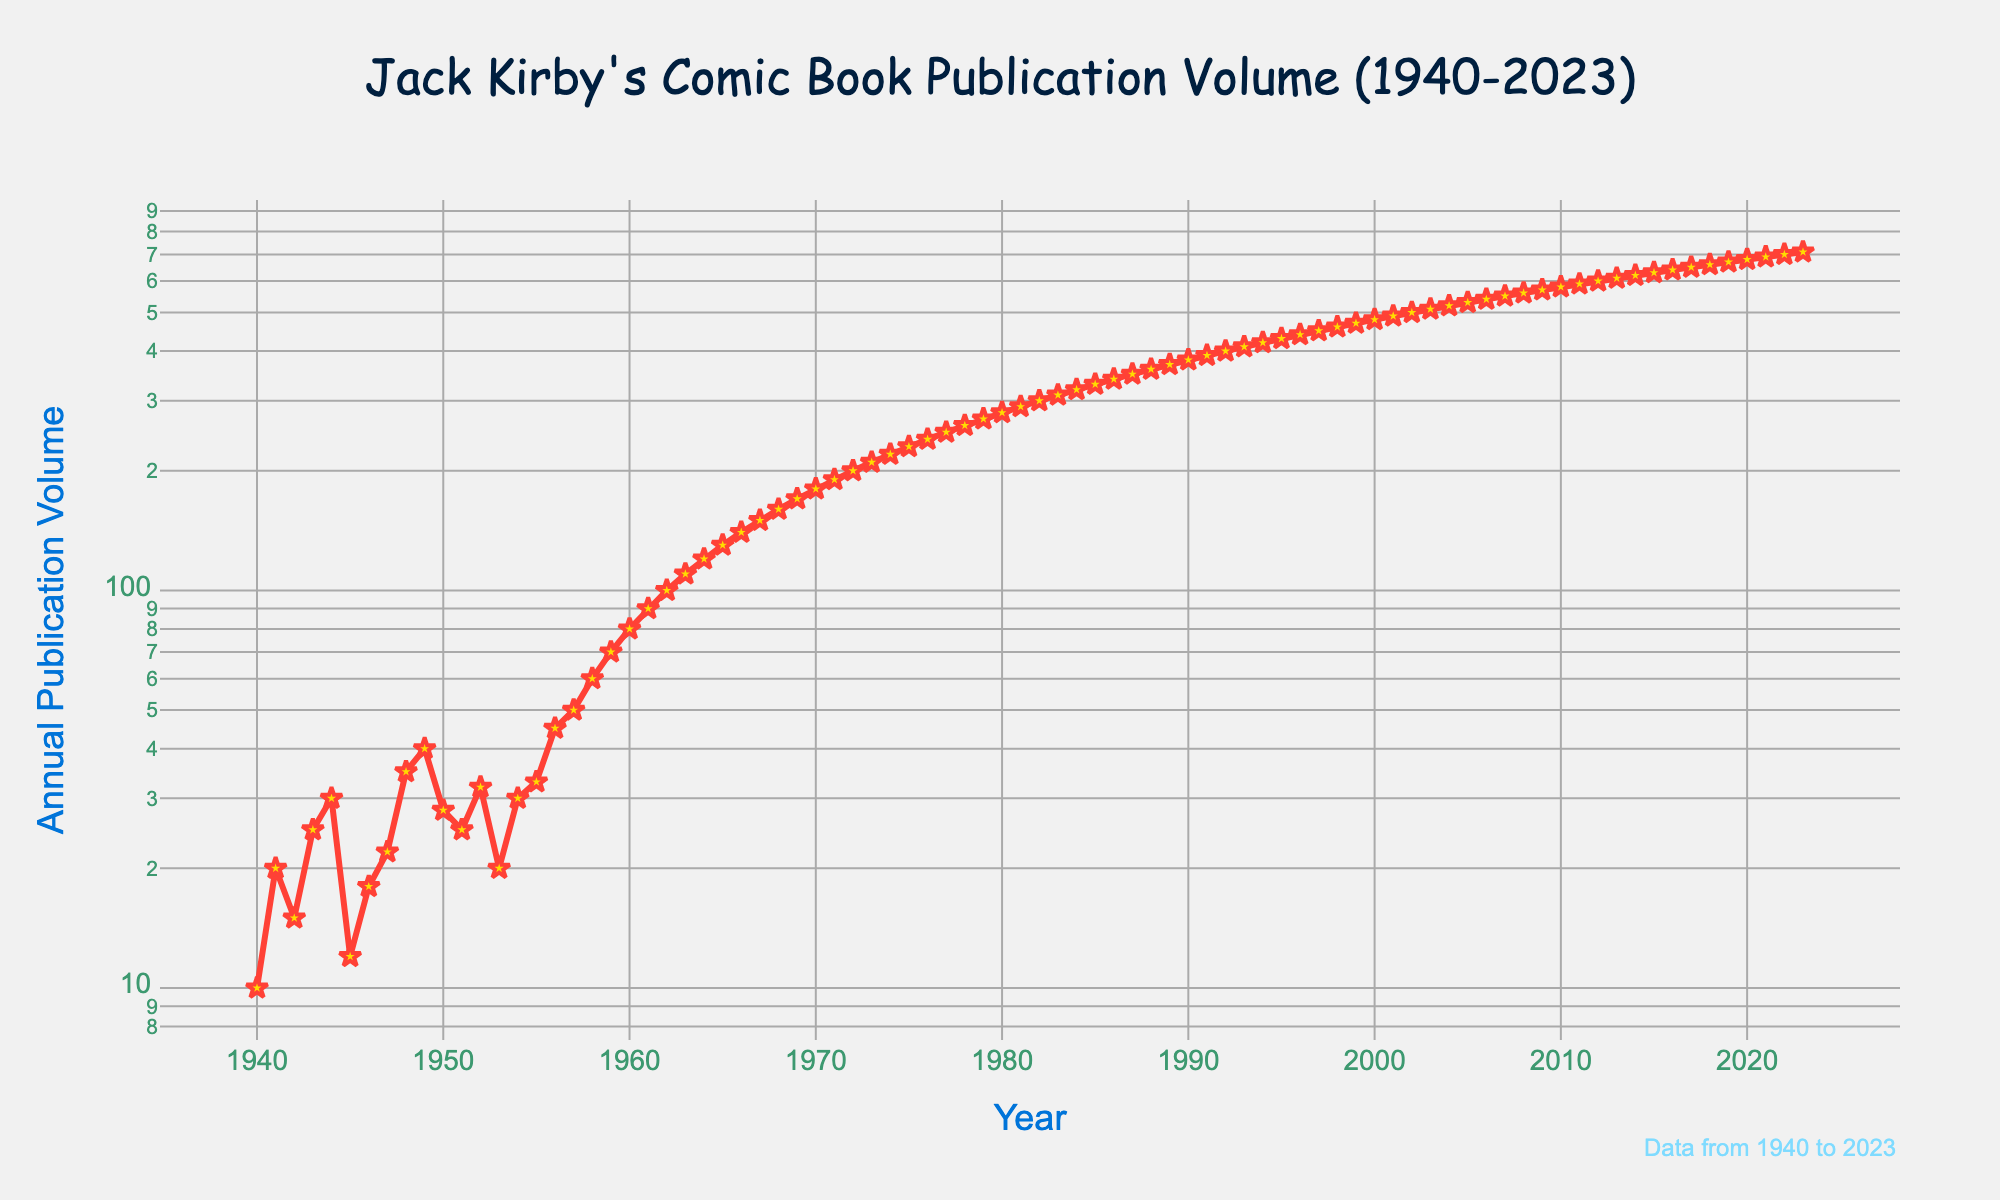What's the title of the plot? The title is displayed at the top of the figure. It reads: "Jack Kirby's Comic Book Publication Volume (1940-2023)".
Answer: Jack Kirby's Comic Book Publication Volume (1940-2023) What are the labels for the x-axis and y-axis? The x-axis and y-axis labels are displayed beneath and beside the axes. The x-axis is labeled "Year" and the y-axis is labeled "Annual Publication Volume".
Answer: Year; Annual Publication Volume What's the annual publication volume of Jack Kirby's comic books in the year 1958? Locate the year 1958 along the x-axis, then trace up to the corresponding y-axis value for that year. The volume for 1958 is 60.
Answer: 60 Is the publication volume consistently increasing from 1940 to 2023? Observing the trend of the line plot over time, we see that the volume generally increases, though there are small fluctuations. Overall, the trend shows an increasing pattern.
Answer: Yes Which year marks the first instance where the publication volume reaches 100? Locate where the y-axis value reaches 100 and trace horizontally to find the corresponding x-axis value. The year is 1962.
Answer: 1962 Between which two consecutive years was the greatest increase in publication volume observed? Examine the steepest segment of the line plot. The steepest segment, indicating the greatest increase, is from 1944 to 1945. This increase, however, is relative to the logarithmic scale.
Answer: 1944 to 1945 What's the median annual publication volume from 1940 to 2023? With 84 data points (years), the median is the average of the 42nd and 43rd values. The volumes for these years (1981 and 1982) are 290 and 300, respectively. The median is (290 + 300) / 2 = 295.
Answer: 295 How does the publication volume in 1940 compare to 2023? To compare visually, note the publication volumes for 1940 (10) and 2023 (710). There is a significant increase from 10 to 710 over the period.
Answer: 2023 is much higher During which decade did the publication volume first exceed 500? By locating the first instance on the y-axis above 500, we see that it occurs in the 2000s, specifically in 2002.
Answer: 2000s What's the approximate annual publication volume in 1970? Locate 1970 on the x-axis and trace to the corresponding y-axis value. The publication volume for 1970 is around 180.
Answer: 180 